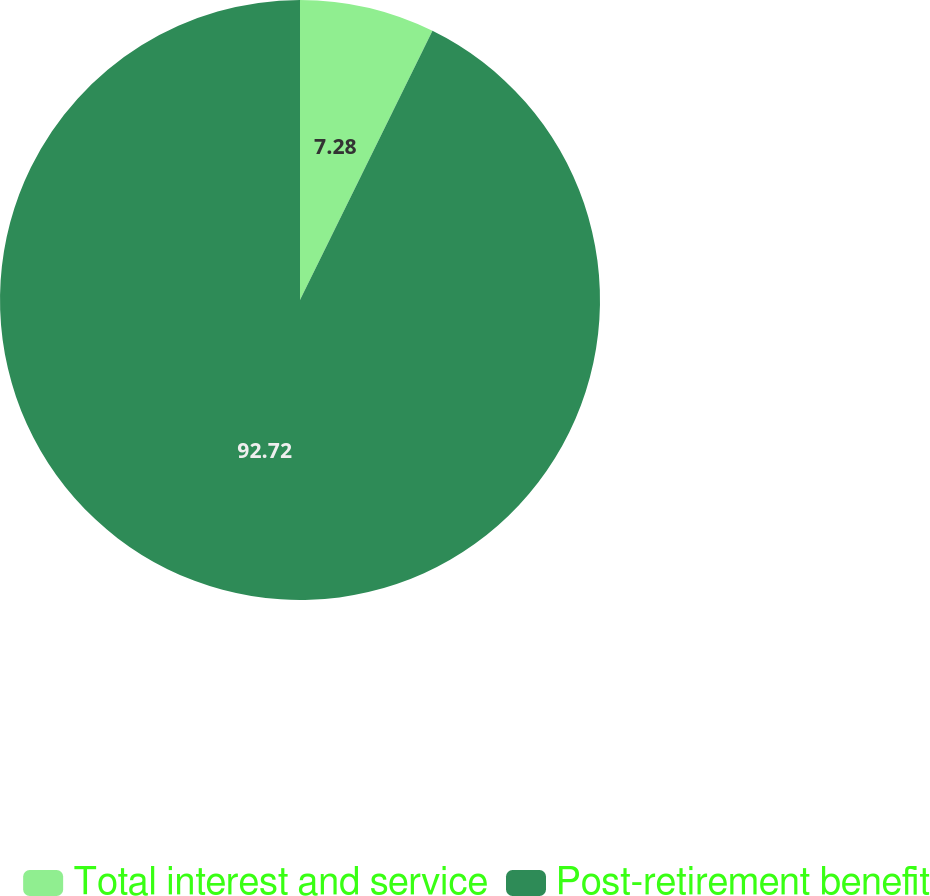Convert chart. <chart><loc_0><loc_0><loc_500><loc_500><pie_chart><fcel>Total interest and service<fcel>Post-retirement benefit<nl><fcel>7.28%<fcel>92.72%<nl></chart> 